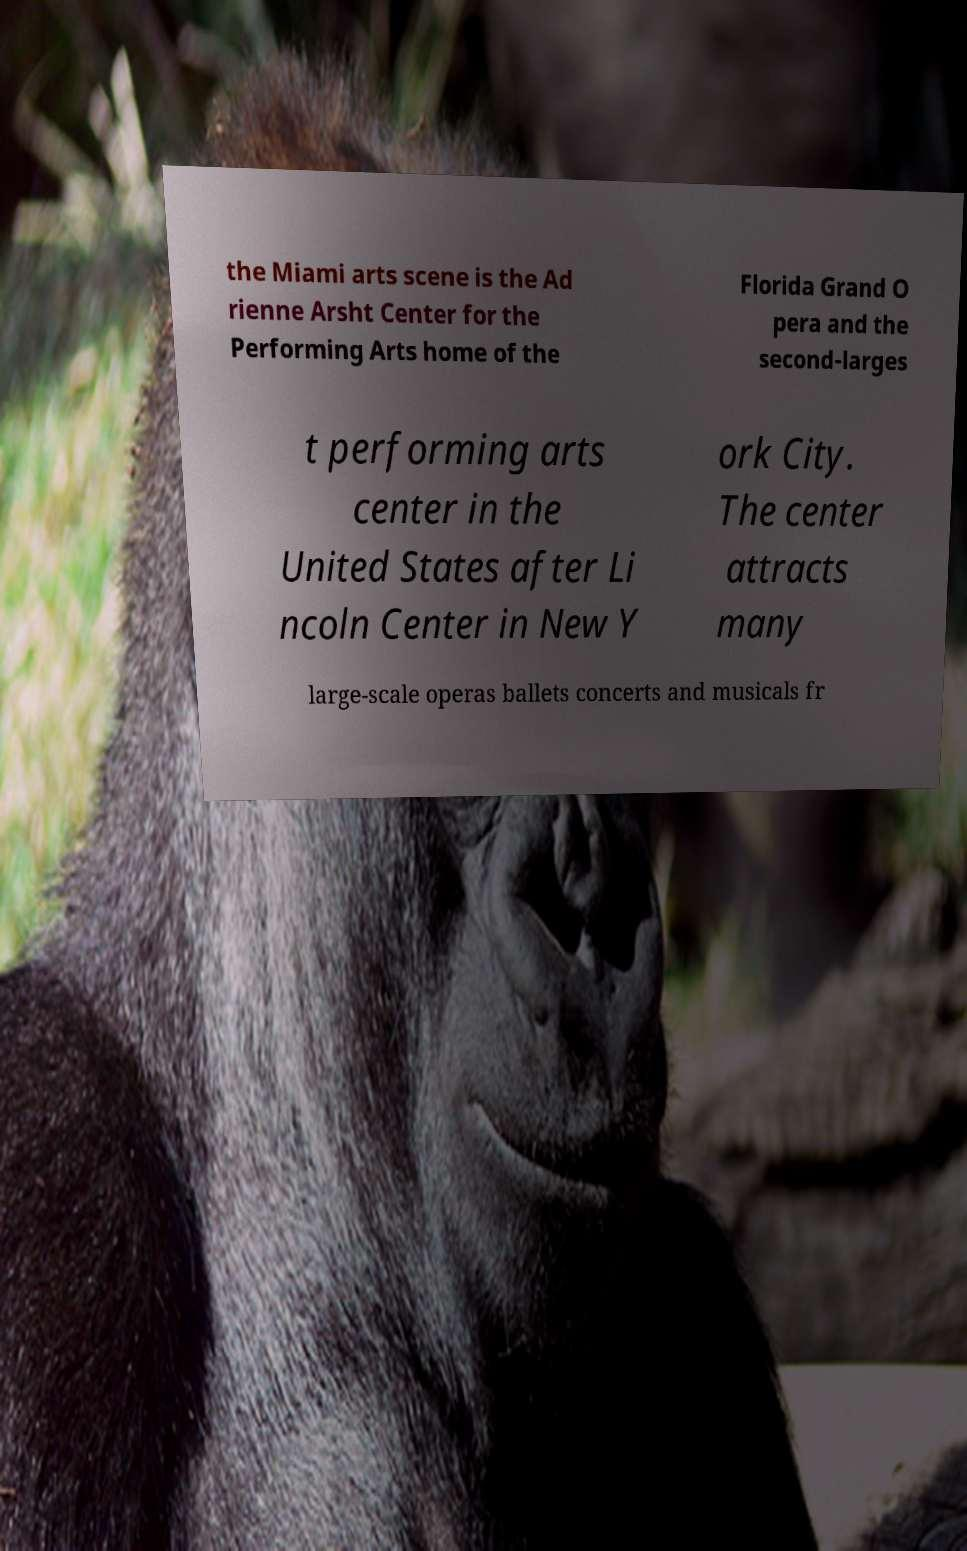Can you read and provide the text displayed in the image?This photo seems to have some interesting text. Can you extract and type it out for me? the Miami arts scene is the Ad rienne Arsht Center for the Performing Arts home of the Florida Grand O pera and the second-larges t performing arts center in the United States after Li ncoln Center in New Y ork City. The center attracts many large-scale operas ballets concerts and musicals fr 